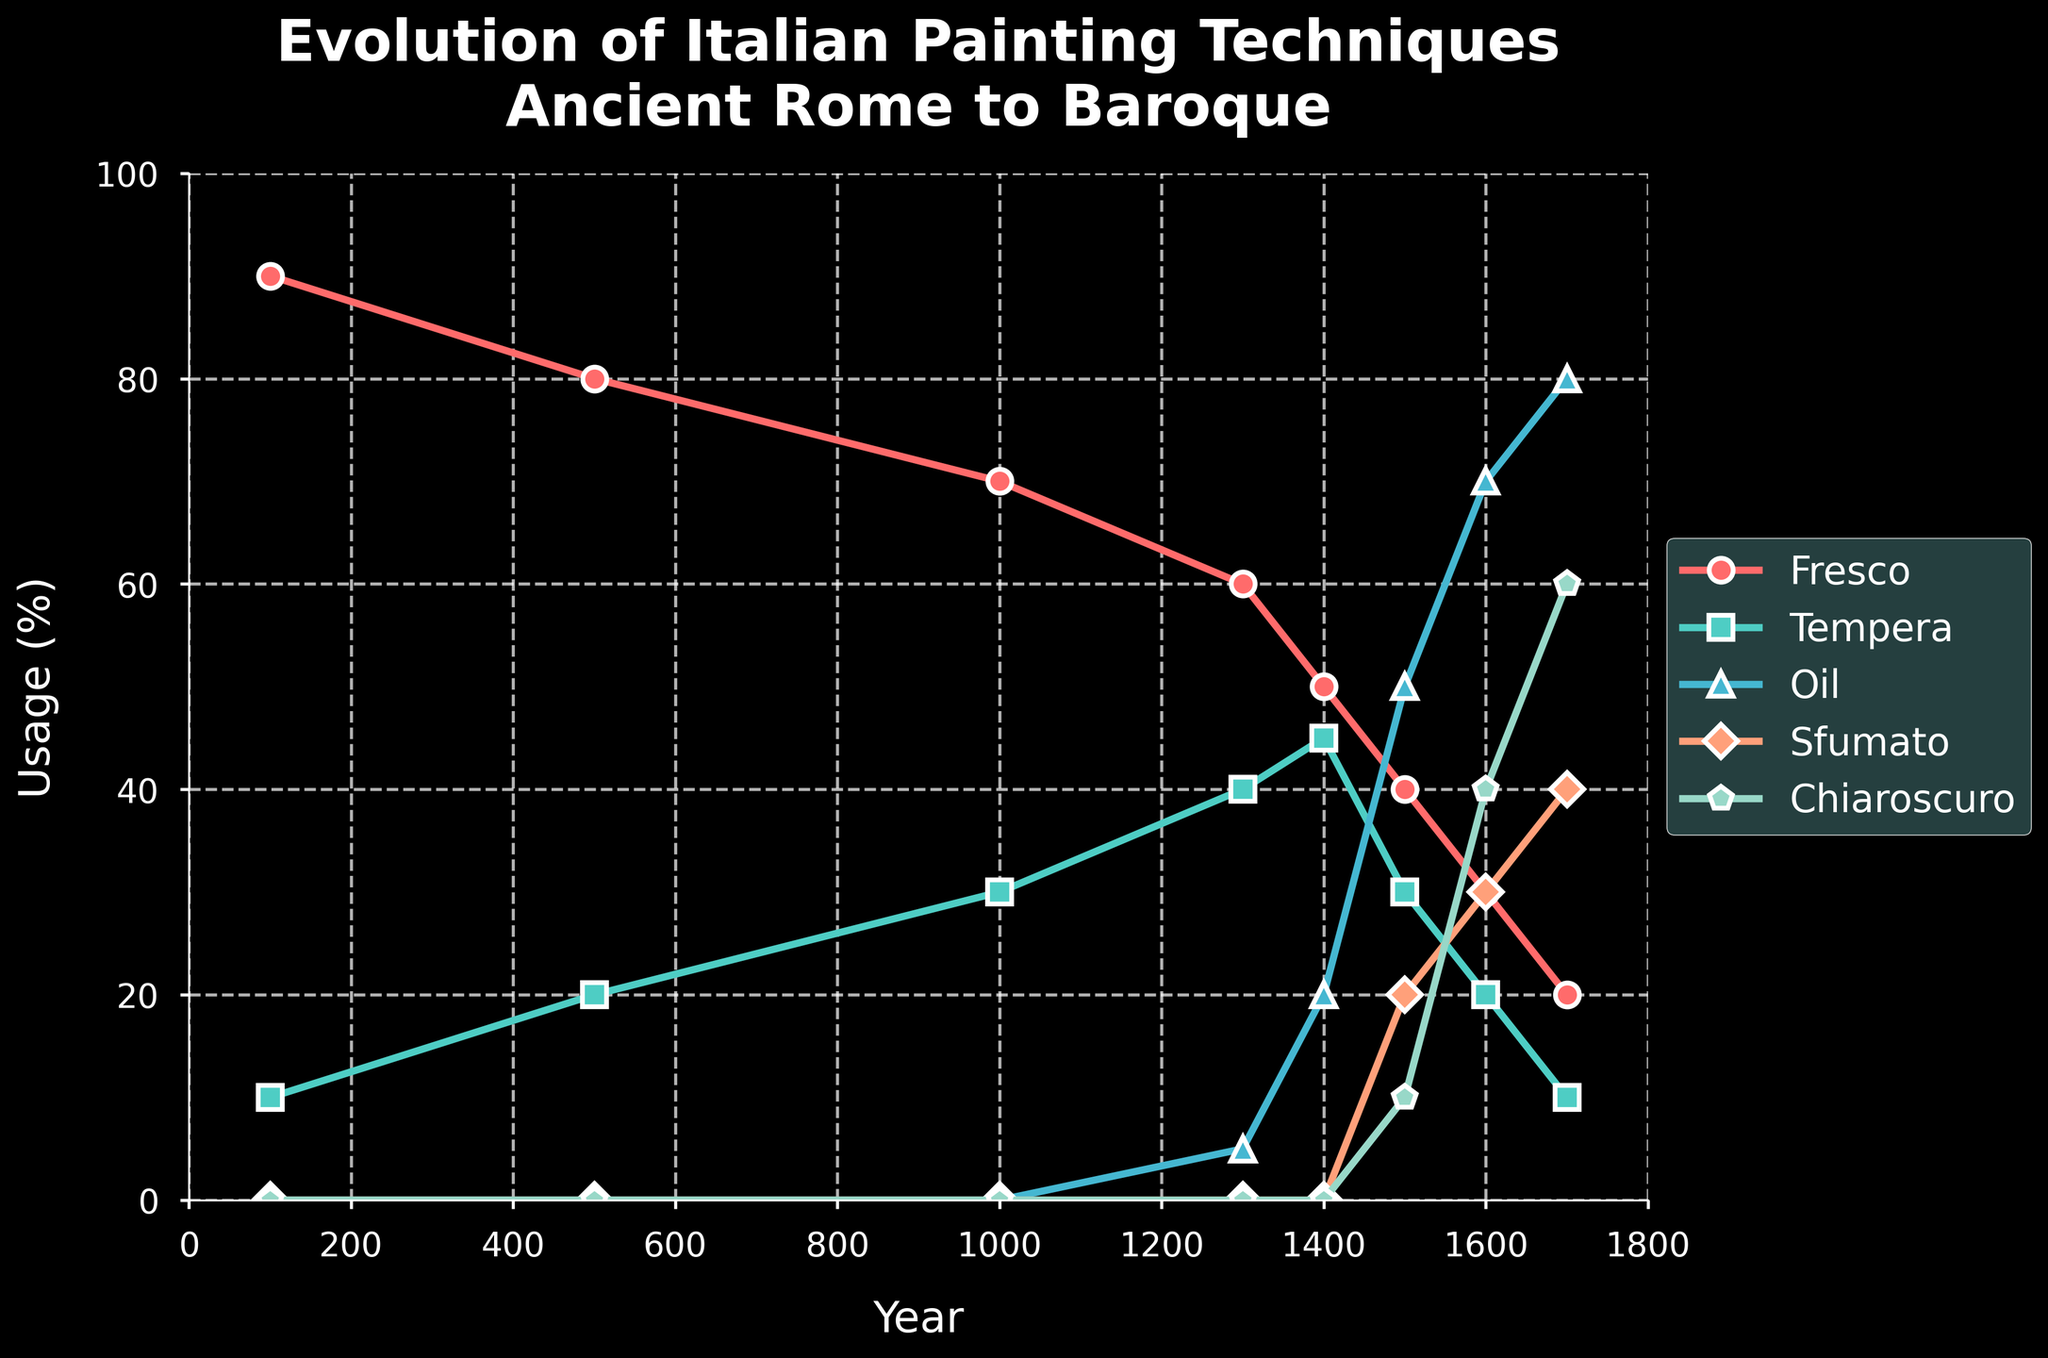What painting technique dominated around the year 100? At the year 100, Fresco (red line) had a usage percentage significantly higher than the others, which all were close to 0.
Answer: Fresco What's the trend for Oil painting from the year 1400 to 1700? Starting from the year 1400, the percentage of Oil painting usage increased steadily from 20% to 80% by the year 1700.
Answer: Increasing Which technique reached its highest peak around the year 1700? By observing the chart around the year 1700, Chiaroscuro (light green line) has the highest peak compared to all other techniques, reaching 60%.
Answer: Chiaroscuro How did the usage percentage of Tempera change between the year 1300 and 1500? Tempera (green line) decreased from 40% in the year 1300 to 30% in the year 1500.
Answer: Decreased What are the small emerging painting techniques introduced around the year 1300? Around the year 1300, both Oil and Sfumato started to be used, although the usage was small at first, around 5% for Oil and none for Sfumato.
Answer: Oil and Sfumato Comparing the usage of Fresco and Chiaroscuro in the year 1600, which was more prevalent? In the year 1600, Fresco (red line) had a usage of 30%, while Chiaroscuro (light green line) had a usage of 40%.
Answer: Chiaroscuro By what year did Sfumato achieve a higher percentage of usage than Tempera? Sfumato (orange line) surpassed Tempera (green line) in the year 1600 when its usage reached 30% compared to Tempera's 20%.
Answer: 1600 Which two techniques had approximately equal usage in the year 1500? In the year 1500, both Oil and Fresco had almost equal usage percentages, around 50% and 40% respectively.
Answer: Oil and Fresco Between which years did Fresco experience a consistent decline? Fresco experienced a consistent decline between the years 100 and 1700, with a sharp decrease in later years.
Answer: 100 to 1700 From the year 1000 to 1300, what was the combined change in Fresco and Tempera usage? Fresco decreased from 70% to 60% (a 10% decrease), and Tempera increased from 30% to 40% (a 10% increase), so the combined change was zero.
Answer: Zero 